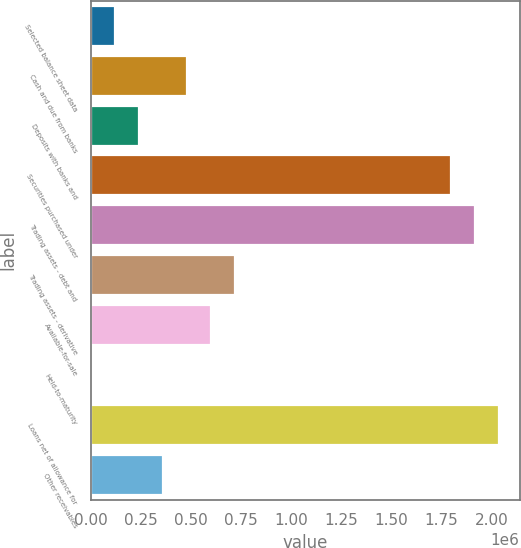Convert chart to OTSL. <chart><loc_0><loc_0><loc_500><loc_500><bar_chart><fcel>Selected balance sheet data<fcel>Cash and due from banks<fcel>Deposits with banks and<fcel>Securities purchased under<fcel>Trading assets - debt and<fcel>Trading assets - derivative<fcel>Available-for-sale<fcel>Held-to-maturity<fcel>Loans net of allowance for<fcel>Other receivables<nl><fcel>119964<fcel>479623<fcel>239850<fcel>1.79837e+06<fcel>1.91826e+06<fcel>719396<fcel>599510<fcel>77<fcel>2.03815e+06<fcel>359736<nl></chart> 